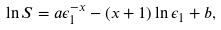Convert formula to latex. <formula><loc_0><loc_0><loc_500><loc_500>\ln S = a \epsilon _ { 1 } ^ { - x } - ( x + 1 ) \ln \epsilon _ { 1 } + b ,</formula> 